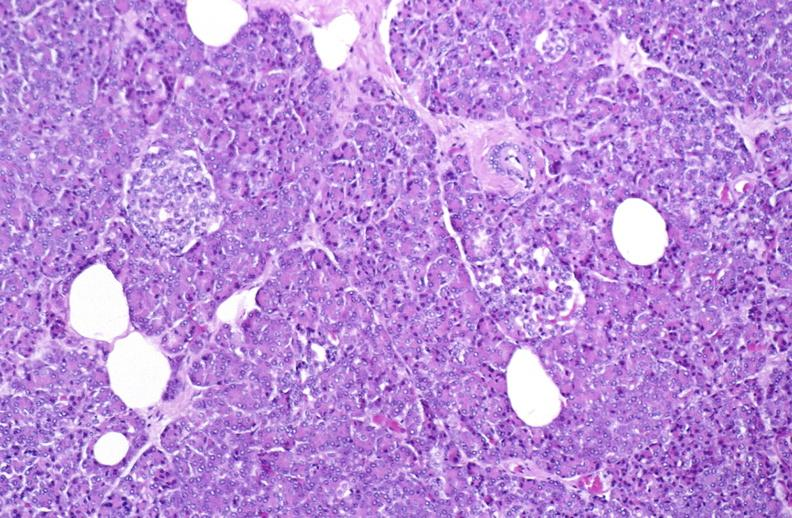what does this image show?
Answer the question using a single word or phrase. Normal pancreas 